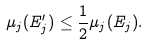Convert formula to latex. <formula><loc_0><loc_0><loc_500><loc_500>\mu _ { j } ( E ^ { \prime } _ { j } ) \leq \frac { 1 } { 2 } \mu _ { j } ( E _ { j } ) .</formula> 